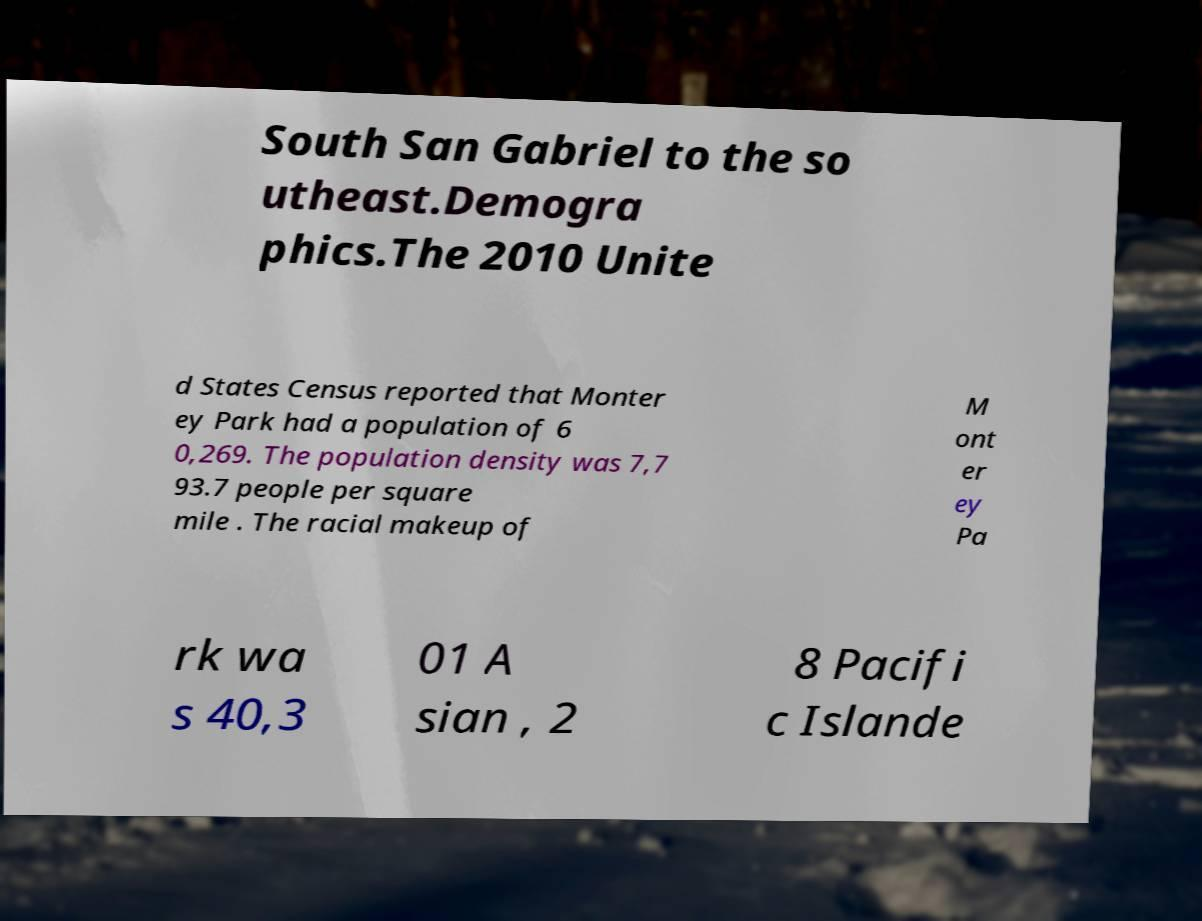Please read and relay the text visible in this image. What does it say? South San Gabriel to the so utheast.Demogra phics.The 2010 Unite d States Census reported that Monter ey Park had a population of 6 0,269. The population density was 7,7 93.7 people per square mile . The racial makeup of M ont er ey Pa rk wa s 40,3 01 A sian , 2 8 Pacifi c Islande 